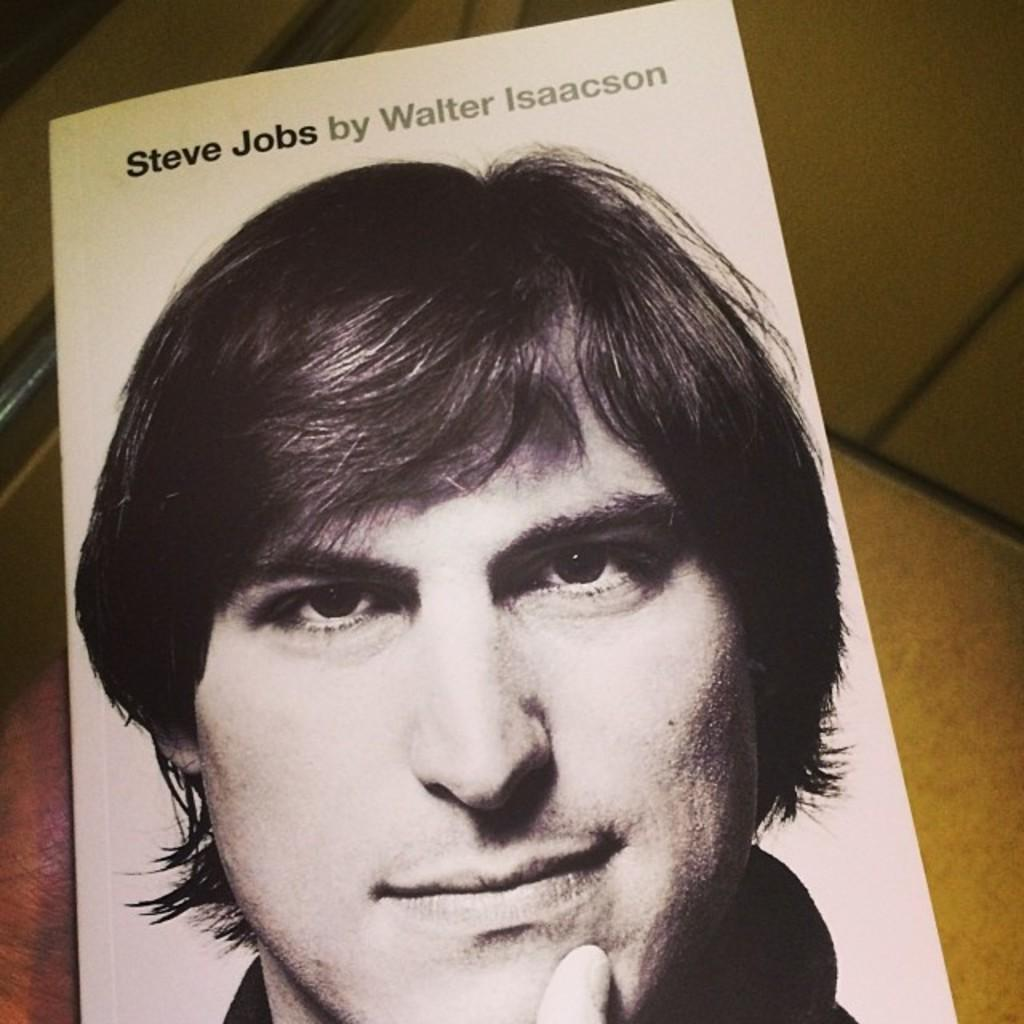What is the main subject of the image? The main subject of the image is a picture of a man. Where is the picture of the man located? The picture of the man is on a book in the image. What type of stew is being prepared by the farmer in the image? There is no farmer or stew present in the image; it only features a picture of a man on a book. What is the man using to secure the chain in the image? There is no chain present in the image; it only features a picture of a man on a book. 